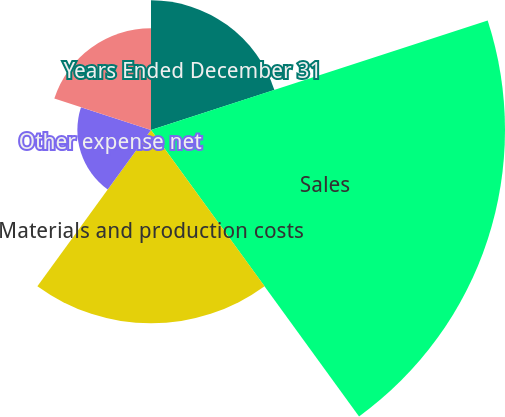Convert chart. <chart><loc_0><loc_0><loc_500><loc_500><pie_chart><fcel>Years Ended December 31<fcel>Sales<fcel>Materials and production costs<fcel>Other expense net<fcel>Income before taxes<nl><fcel>15.22%<fcel>41.54%<fcel>22.68%<fcel>8.64%<fcel>11.93%<nl></chart> 